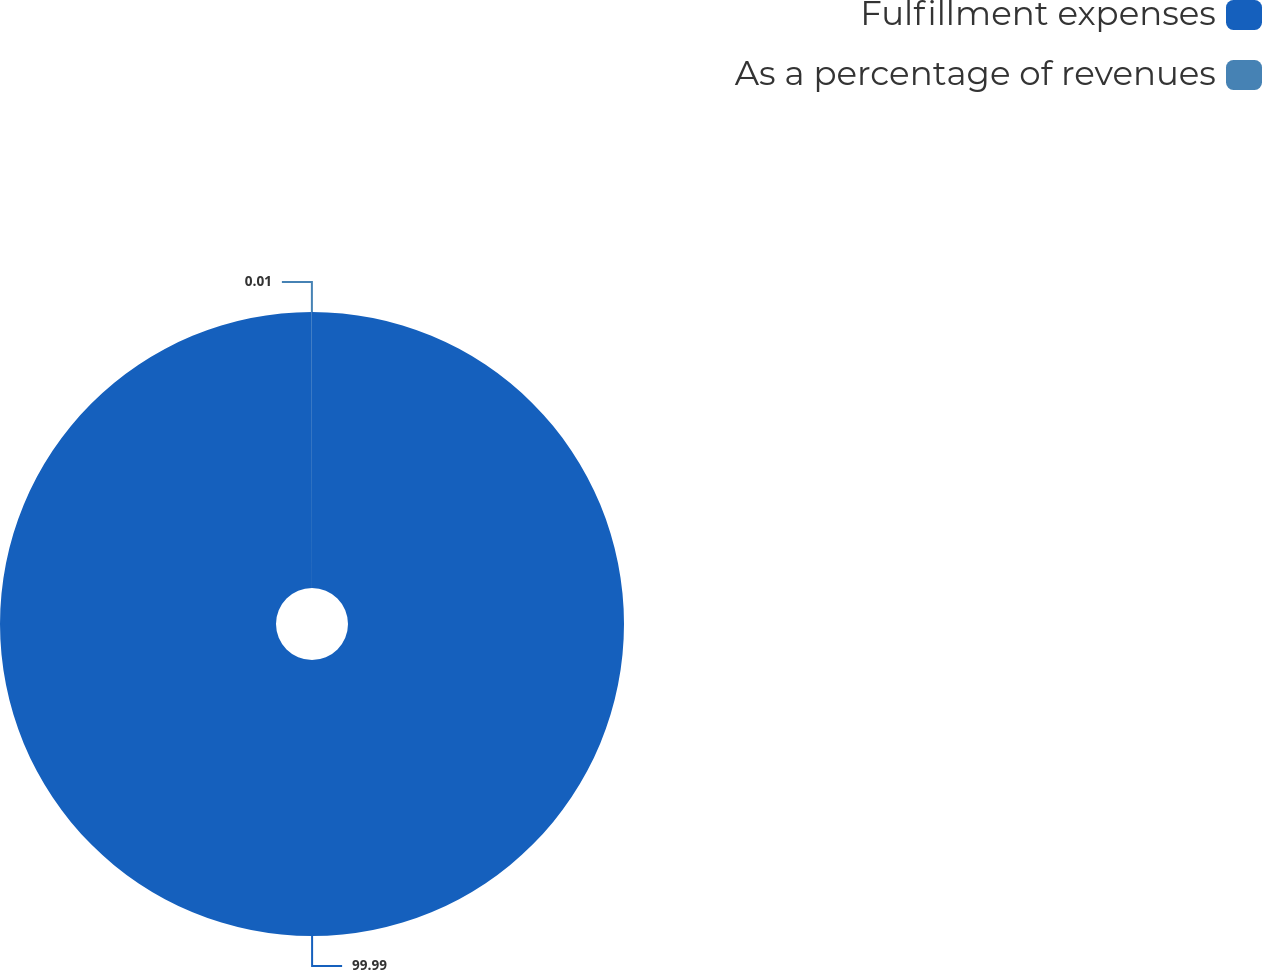<chart> <loc_0><loc_0><loc_500><loc_500><pie_chart><fcel>Fulfillment expenses<fcel>As a percentage of revenues<nl><fcel>99.99%<fcel>0.01%<nl></chart> 